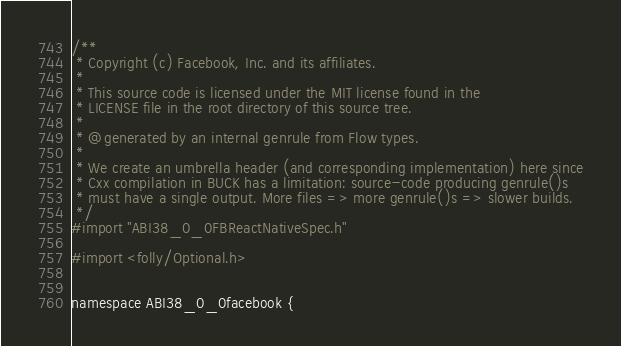<code> <loc_0><loc_0><loc_500><loc_500><_ObjectiveC_>/**
 * Copyright (c) Facebook, Inc. and its affiliates.
 *
 * This source code is licensed under the MIT license found in the
 * LICENSE file in the root directory of this source tree.
 *
 * @generated by an internal genrule from Flow types.
 *
 * We create an umbrella header (and corresponding implementation) here since
 * Cxx compilation in BUCK has a limitation: source-code producing genrule()s
 * must have a single output. More files => more genrule()s => slower builds.
 */
#import "ABI38_0_0FBReactNativeSpec.h"

#import <folly/Optional.h>


namespace ABI38_0_0facebook {</code> 